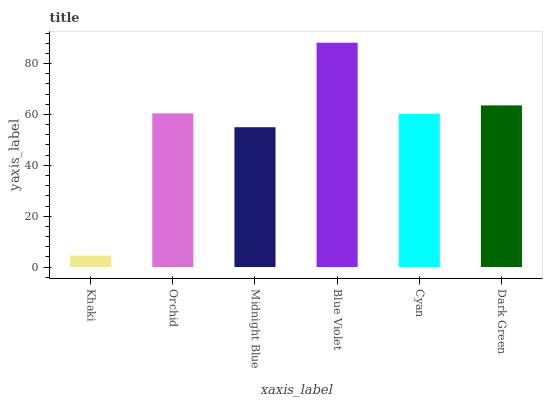Is Khaki the minimum?
Answer yes or no. Yes. Is Blue Violet the maximum?
Answer yes or no. Yes. Is Orchid the minimum?
Answer yes or no. No. Is Orchid the maximum?
Answer yes or no. No. Is Orchid greater than Khaki?
Answer yes or no. Yes. Is Khaki less than Orchid?
Answer yes or no. Yes. Is Khaki greater than Orchid?
Answer yes or no. No. Is Orchid less than Khaki?
Answer yes or no. No. Is Orchid the high median?
Answer yes or no. Yes. Is Cyan the low median?
Answer yes or no. Yes. Is Blue Violet the high median?
Answer yes or no. No. Is Orchid the low median?
Answer yes or no. No. 